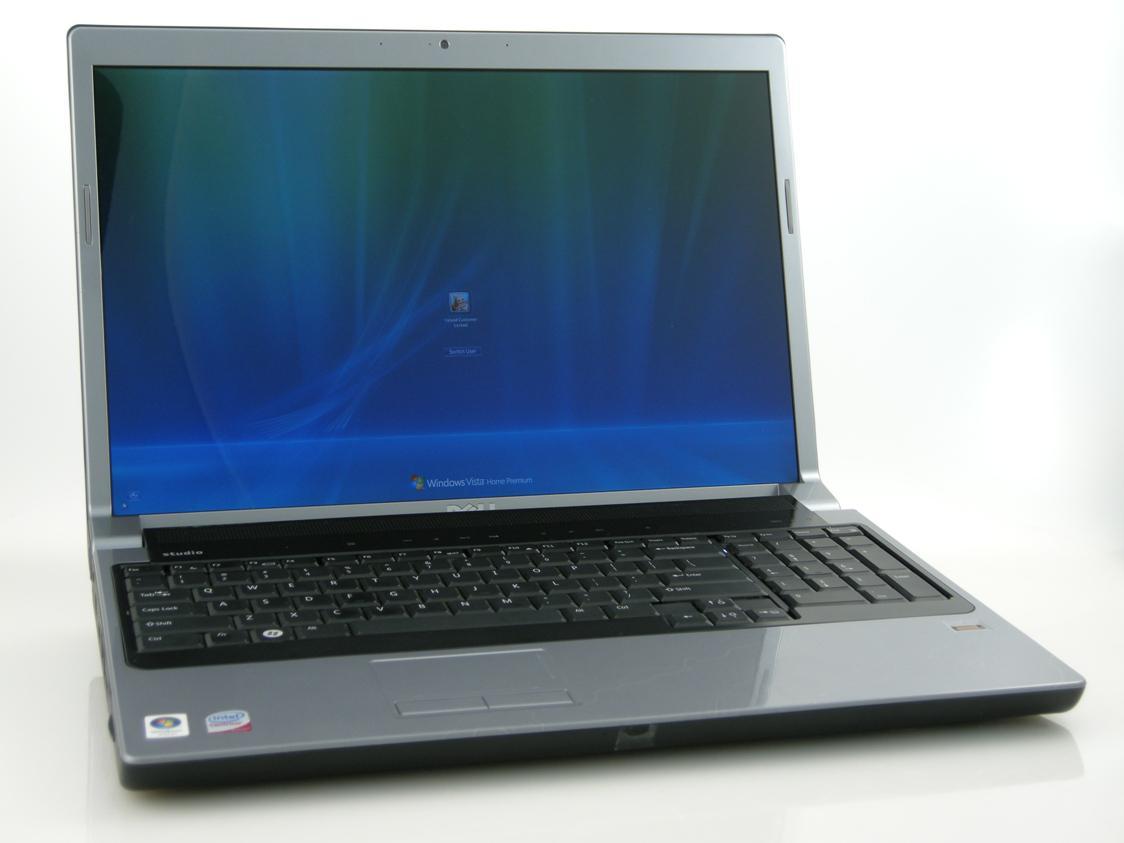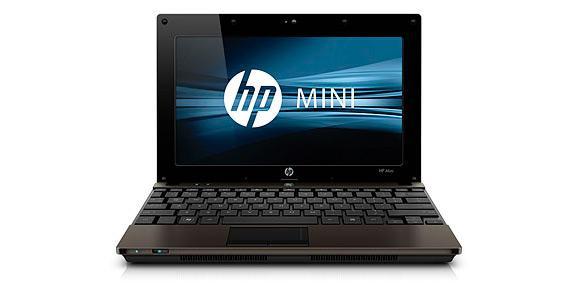The first image is the image on the left, the second image is the image on the right. For the images displayed, is the sentence "The computer displays have the same background image." factually correct? Answer yes or no. No. The first image is the image on the left, the second image is the image on the right. Considering the images on both sides, is "The open laptop on the left is viewed head-on, and the open laptop on the right is displayed at an angle." valid? Answer yes or no. No. 